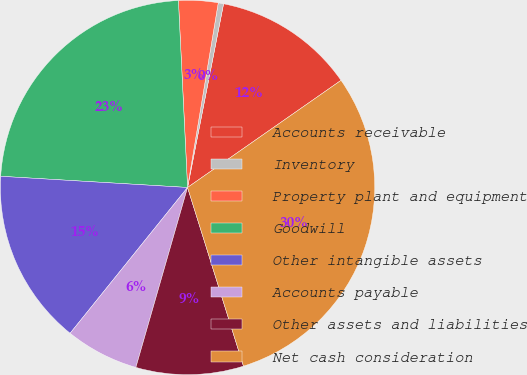<chart> <loc_0><loc_0><loc_500><loc_500><pie_chart><fcel>Accounts receivable<fcel>Inventory<fcel>Property plant and equipment<fcel>Goodwill<fcel>Other intangible assets<fcel>Accounts payable<fcel>Other assets and liabilities<fcel>Net cash consideration<nl><fcel>12.22%<fcel>0.46%<fcel>3.4%<fcel>23.27%<fcel>15.16%<fcel>6.34%<fcel>9.28%<fcel>29.87%<nl></chart> 